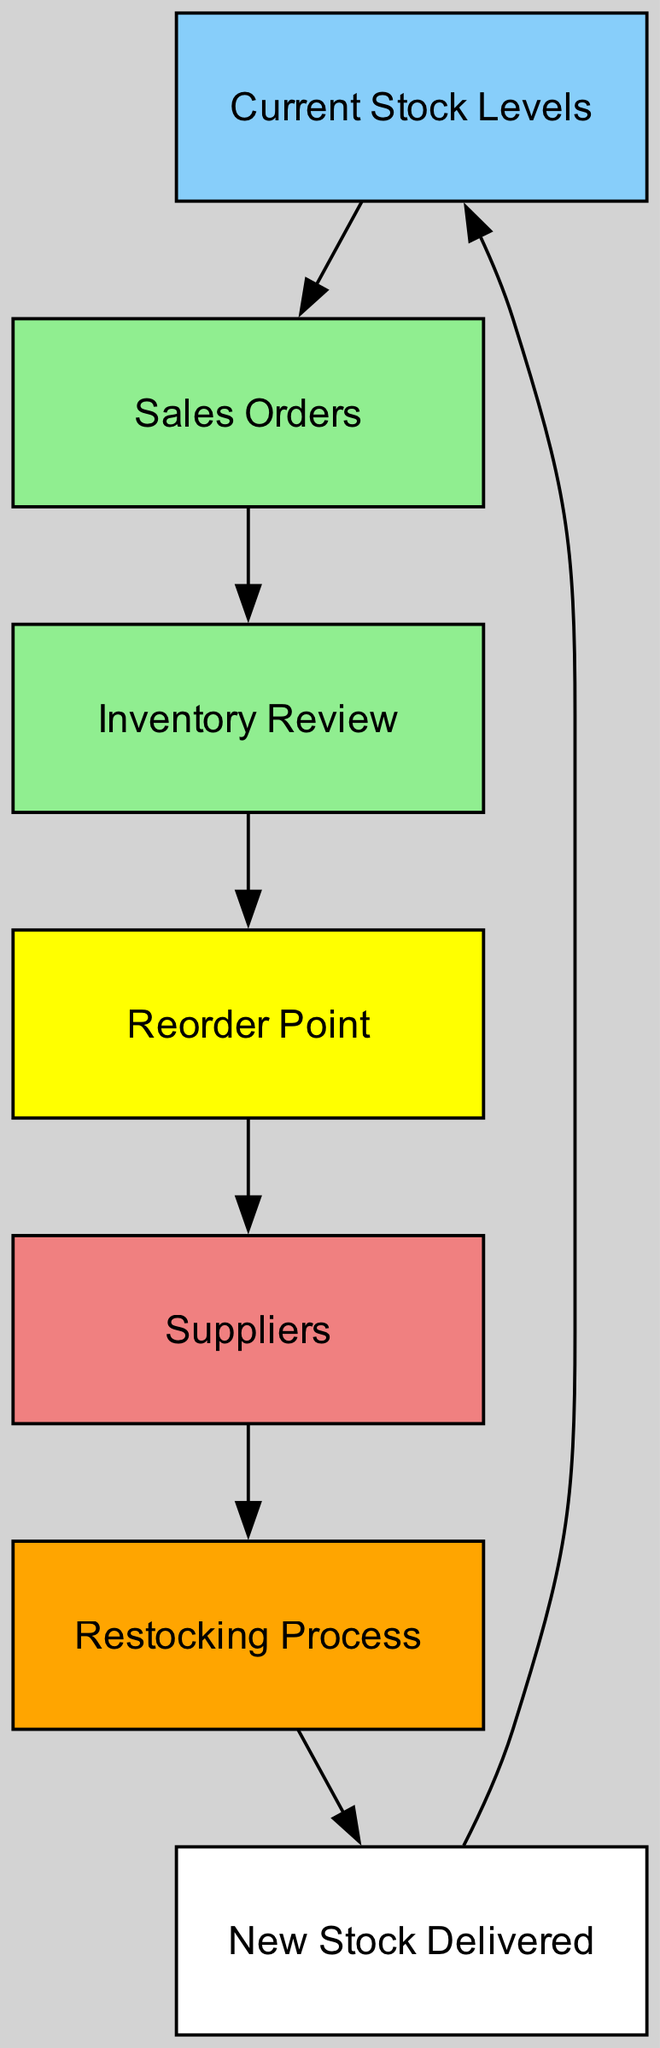What is the total number of nodes in the diagram? The diagram consists of 7 nodes: Current Stock Levels, Sales Orders, Inventory Review, Reorder Point, Suppliers, Restocking Process, and New Stock Delivered.
Answer: 7 What is the first node in the flow? The flow begins with the node labeled "Current Stock Levels."
Answer: Current Stock Levels Which node is connected directly to "Sales Orders"? "Sales Orders" is directly connected to the node labeled "Inventory Review."
Answer: Inventory Review What color represents the "Restocking Process" node? The "Restocking Process" node is represented in orange.
Answer: Orange What follows after the "Reorder Point"? After the "Reorder Point," the next node is "Suppliers."
Answer: Suppliers Which node leads to the "New Stock Delivered"? The node that leads to "New Stock Delivered" is "Restocking Process."
Answer: Restocking Process What is the relation between "Suppliers" and "New Stock Delivered"? "Suppliers" is directly connected to "Restocking Process," which then leads to "New Stock Delivered."
Answer: Restocking Process How many edges are in the diagram? The diagram contains 6 edges that illustrate the flow between the nodes.
Answer: 6 Which node acts as a trigger for the inventory review process? The node "Sales Orders" triggers the inventory review process.
Answer: Sales Orders How does the flow start with stock levels? The flow starts with "Current Stock Levels," which influences "Sales Orders" based on available stock.
Answer: Current Stock Levels 